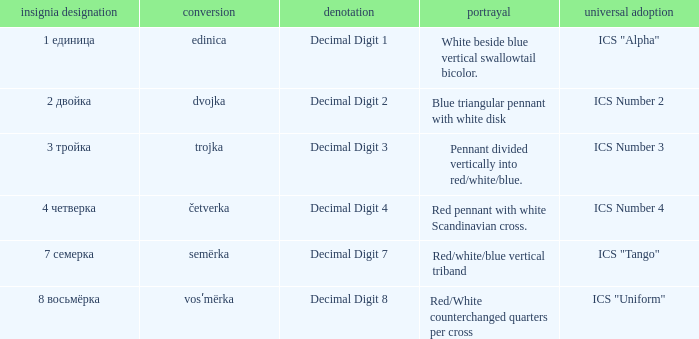What are the meanings of the flag whose name transliterates to dvojka? Decimal Digit 2. 